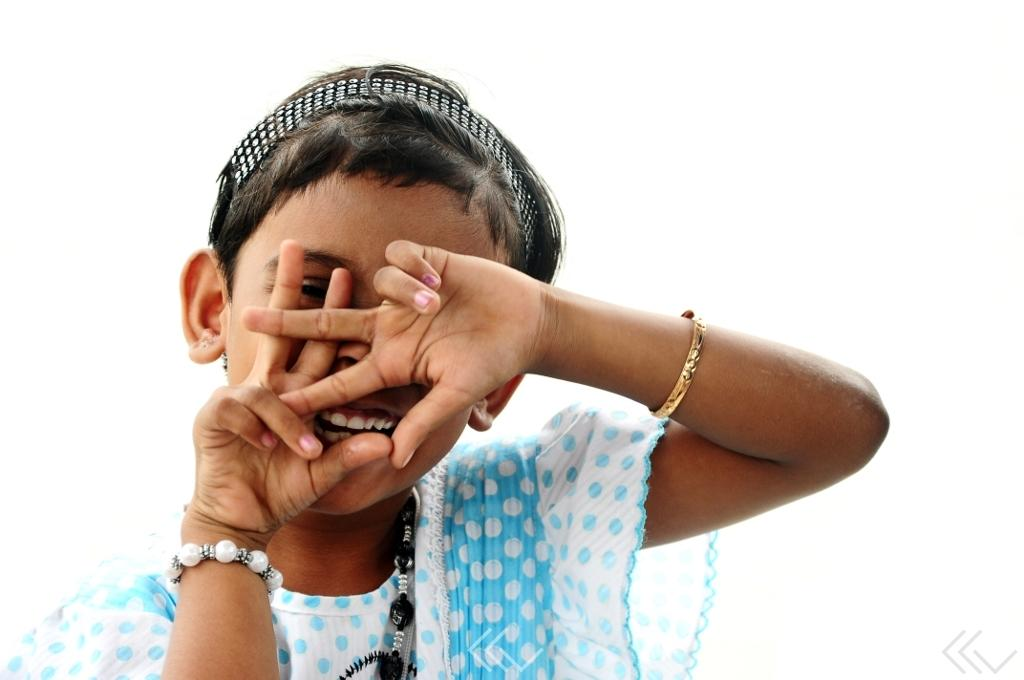Who is present in the image? There is a girl in the image. What is the girl's expression in the image? The girl is smiling in the image. Is there a beggar in the image? No, there is no beggar present in the image. The image only features a girl who is smiling. 